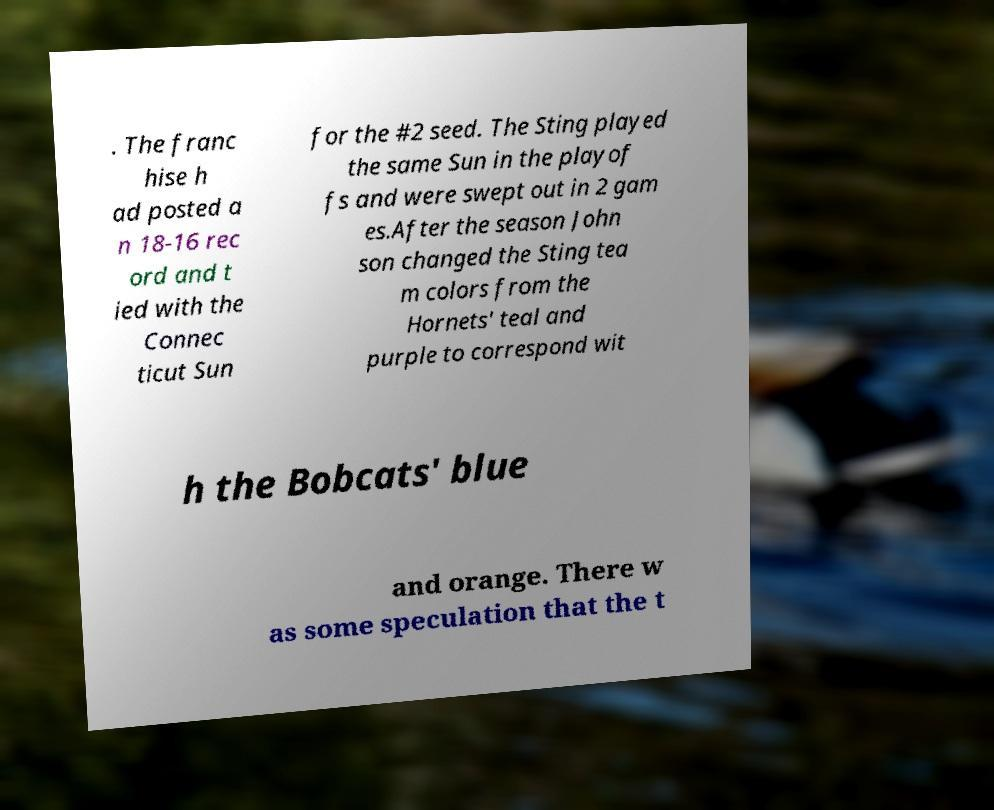There's text embedded in this image that I need extracted. Can you transcribe it verbatim? . The franc hise h ad posted a n 18-16 rec ord and t ied with the Connec ticut Sun for the #2 seed. The Sting played the same Sun in the playof fs and were swept out in 2 gam es.After the season John son changed the Sting tea m colors from the Hornets' teal and purple to correspond wit h the Bobcats' blue and orange. There w as some speculation that the t 